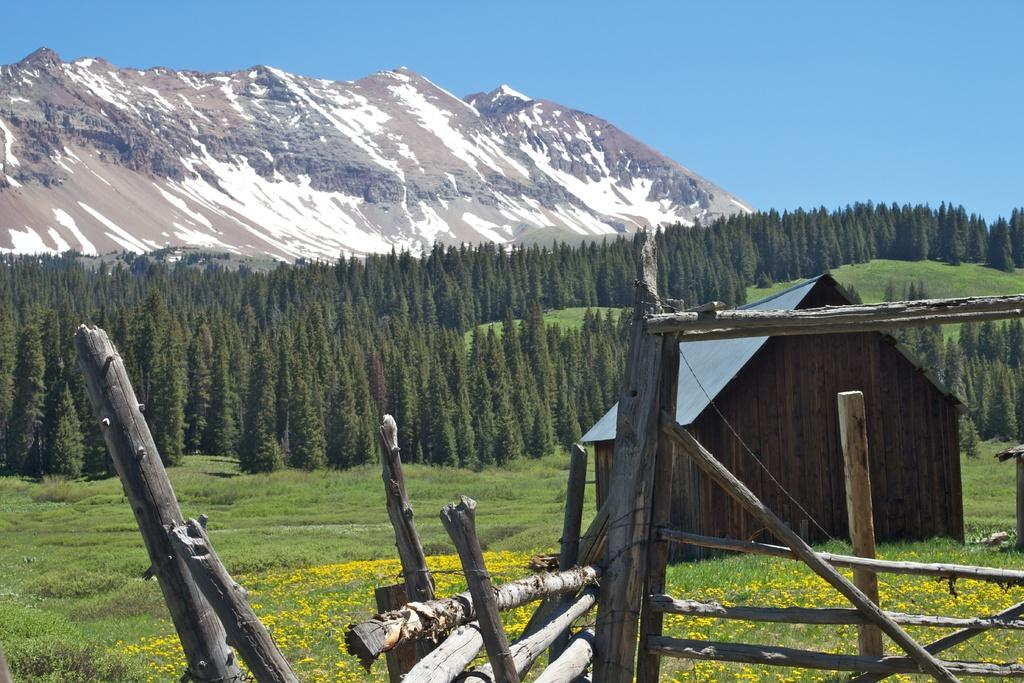What type of structure is visible in the image? There is a house in the image. What other objects can be seen in the image? Wooden poles, plants, trees, and flowers are present in the image. Are there any natural landmarks visible in the image? Yes, there are mountains in the image. What part of the natural environment is visible in the image? The sky is visible in the image. What type of alley can be seen in the image? There is no alley present in the image. What is being exchanged between the plants and flowers in the image? There is no exchange happening between the plants and flowers in the image; they are simply present in the scene. 